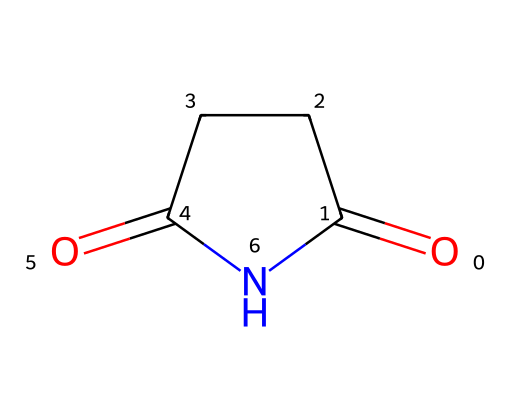What is the molecular formula of succinimide? To determine the molecular formula, count the number of carbon (C), hydrogen (H), nitrogen (N), and oxygen (O) atoms in the structure based on the SMILES representation. There are 4 carbon atoms, 5 hydrogen atoms, 1 nitrogen atom, and 2 oxygen atoms. Therefore, the molecular formula is C4H5NO2.
Answer: C4H5NO2 How many nitrogen atoms are present in this structure? The SMILES representation shows there is one nitrogen atom (indicated by 'N').
Answer: 1 What type of functional groups are present in succinimide? The structure contains an imide functional group, characterized by the carbonyl and nitrogen atom arrangement. The presence of carbonyl (C=O) and nitrogen (N) confirms it.
Answer: imide What is the total number of rings in succinimide? By analyzing the structure, it is visible that this molecule contains one cycle or ring (noted by the '1' in the SMILES that indicates cyclic structure).
Answer: 1 What is the hybridization of the nitrogen atom in succinimide? The nitrogen atom is part of the imide group, which is sp2 hybridized due to the presence of a double bond with a carbon atom and it being part of a ring.
Answer: sp2 Does succinimide participate in post-translational modifications in proteins? Yes, succinimide can form covalent bonds with amino acid side chains, allowing for the modification of proteins through processes such as amide bond formation.
Answer: Yes 